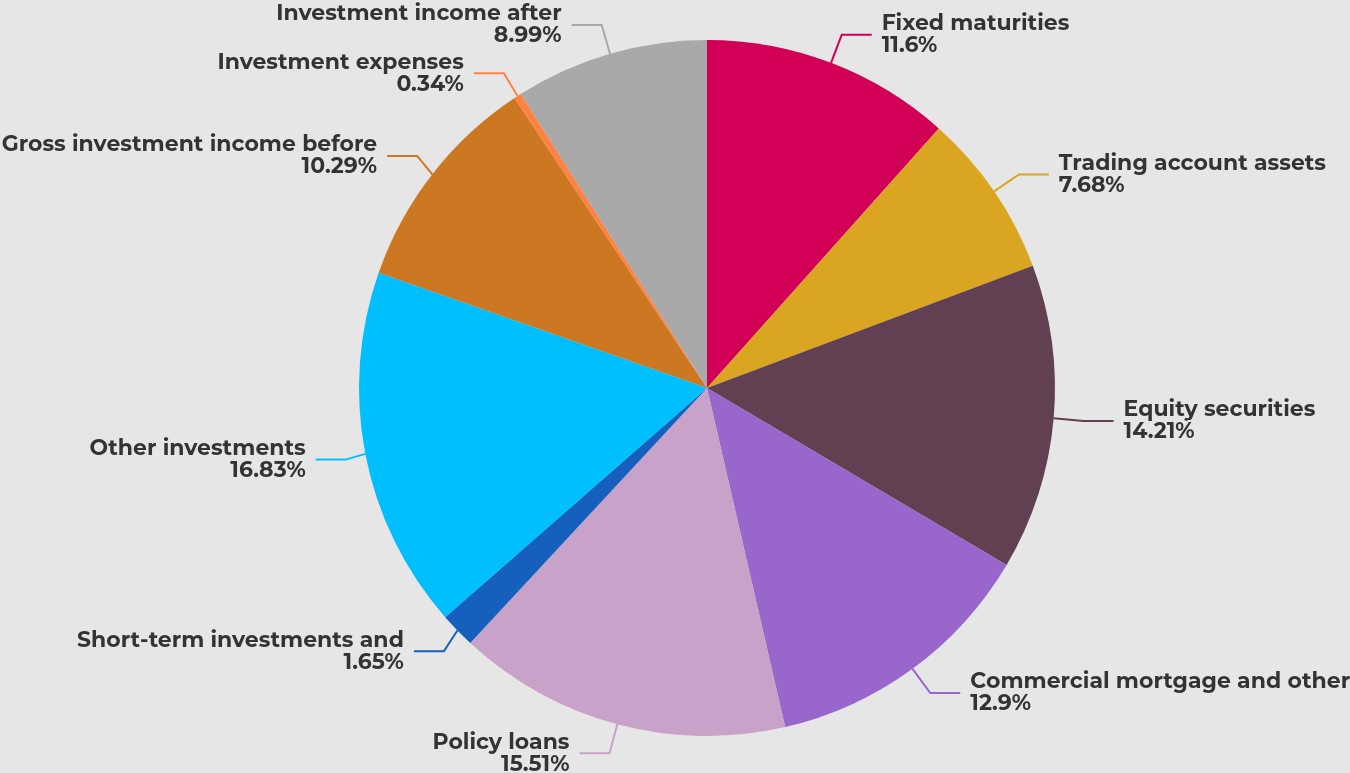Convert chart. <chart><loc_0><loc_0><loc_500><loc_500><pie_chart><fcel>Fixed maturities<fcel>Trading account assets<fcel>Equity securities<fcel>Commercial mortgage and other<fcel>Policy loans<fcel>Short-term investments and<fcel>Other investments<fcel>Gross investment income before<fcel>Investment expenses<fcel>Investment income after<nl><fcel>11.6%<fcel>7.68%<fcel>14.21%<fcel>12.9%<fcel>15.51%<fcel>1.65%<fcel>16.82%<fcel>10.29%<fcel>0.34%<fcel>8.99%<nl></chart> 